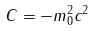Convert formula to latex. <formula><loc_0><loc_0><loc_500><loc_500>C = - m _ { 0 } ^ { 2 } c ^ { 2 }</formula> 